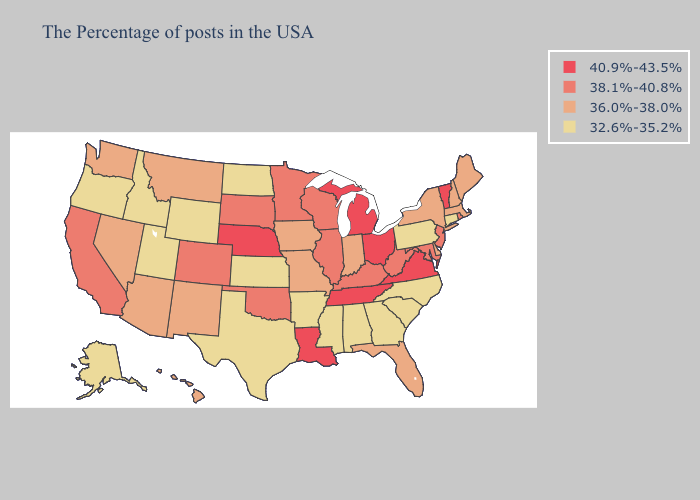What is the highest value in states that border Nebraska?
Be succinct. 38.1%-40.8%. What is the highest value in the USA?
Be succinct. 40.9%-43.5%. Does New Jersey have the lowest value in the USA?
Concise answer only. No. Does Kansas have the lowest value in the MidWest?
Write a very short answer. Yes. Which states have the highest value in the USA?
Short answer required. Vermont, Virginia, Ohio, Michigan, Tennessee, Louisiana, Nebraska. Which states have the highest value in the USA?
Quick response, please. Vermont, Virginia, Ohio, Michigan, Tennessee, Louisiana, Nebraska. Does Vermont have the highest value in the USA?
Answer briefly. Yes. Does North Dakota have the lowest value in the MidWest?
Keep it brief. Yes. What is the value of Colorado?
Quick response, please. 38.1%-40.8%. What is the lowest value in states that border Alabama?
Short answer required. 32.6%-35.2%. Does Louisiana have the highest value in the USA?
Write a very short answer. Yes. Among the states that border Nebraska , does Kansas have the highest value?
Give a very brief answer. No. What is the value of Iowa?
Answer briefly. 36.0%-38.0%. Which states have the lowest value in the USA?
Concise answer only. Connecticut, Pennsylvania, North Carolina, South Carolina, Georgia, Alabama, Mississippi, Arkansas, Kansas, Texas, North Dakota, Wyoming, Utah, Idaho, Oregon, Alaska. Does Vermont have the highest value in the Northeast?
Write a very short answer. Yes. 